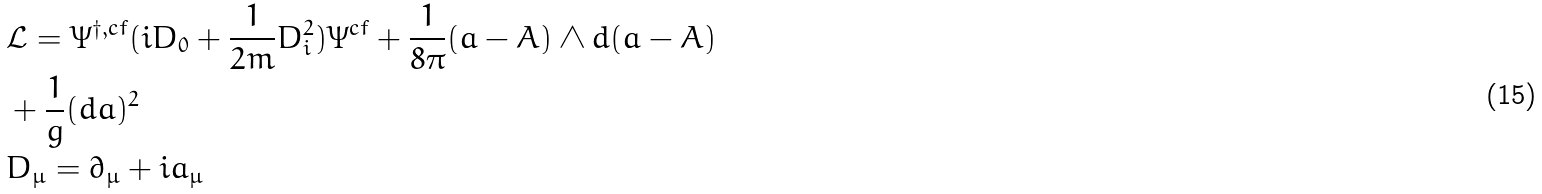<formula> <loc_0><loc_0><loc_500><loc_500>& \mathcal { L } = \Psi ^ { \dagger , c f } ( i D _ { 0 } + \frac { 1 } { 2 m } D ^ { 2 } _ { i } ) \Psi ^ { c f } + \frac { 1 } { 8 \pi } ( a - A ) \wedge d ( a - A ) \\ & + \frac { 1 } { g } ( d a ) ^ { 2 } \\ & D _ { \mu } = \partial _ { \mu } + i a _ { \mu }</formula> 